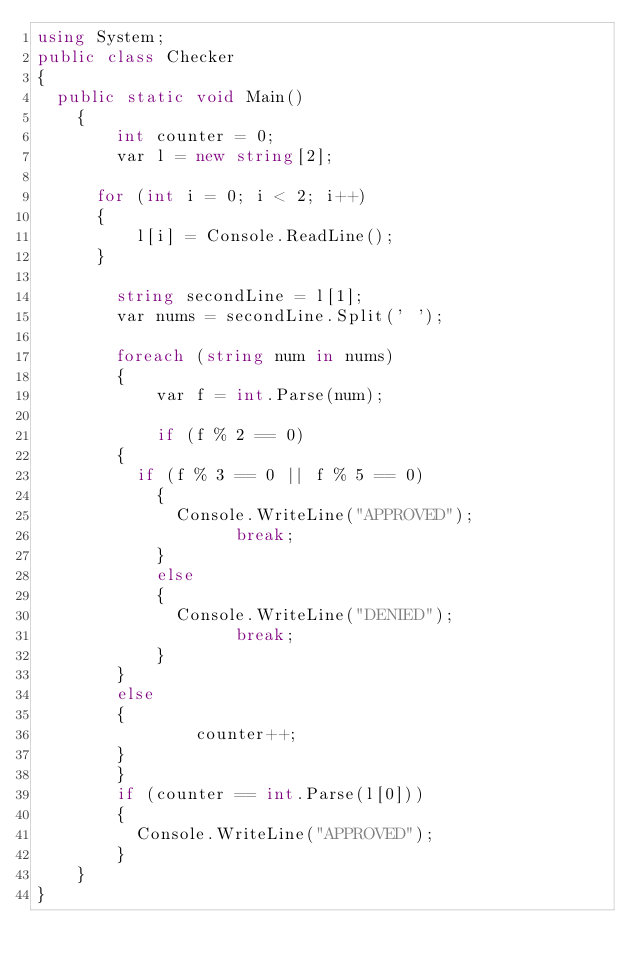Convert code to text. <code><loc_0><loc_0><loc_500><loc_500><_C#_>using System;
public class Checker
{
	public static void Main()
  	{
      	int counter = 0;
      	var l = new string[2];
      
    	for (int i = 0; i < 2; i++)
    	{
        	l[i] = Console.ReadLine();
    	}
      
      	string secondLine = l[1];
      	var nums = secondLine.Split(' ');
      
      	foreach (string num in nums)
        {
          	var f = int.Parse(num);
          
          	if (f % 2 == 0)
    		{
    			if (f % 3 == 0 || f % 5 == 0)
        		{
        			Console.WriteLine("APPROVED");
                  	break;
        		}
      			else
        		{
        			Console.WriteLine("DENIED");
                  	break;
        		}
    		}
  			else
    		{
              	counter++;
    		}
        }
      	if (counter == int.Parse(l[0]))
        {
        	Console.WriteLine("APPROVED");
        }
  	}
}</code> 